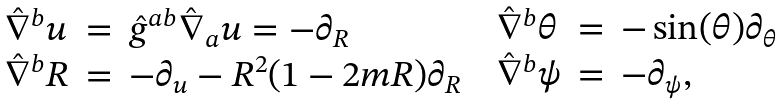<formula> <loc_0><loc_0><loc_500><loc_500>\begin{array} { c c } \begin{array} { l c l } \hat { \nabla } ^ { b } u & = & \hat { g } ^ { a b } \hat { \nabla } _ { a } u = - \partial _ { R } \\ \hat { \nabla } ^ { b } R & = & - \partial _ { u } - R ^ { 2 } ( 1 - 2 m R ) \partial _ { R } \end{array} & \begin{array} { l c l } \hat { \nabla } ^ { b } \theta & = & - \sin ( \theta ) \partial _ { \theta } \\ \hat { \nabla } ^ { b } \psi & = & - \partial _ { \psi } , \end{array} \end{array}</formula> 